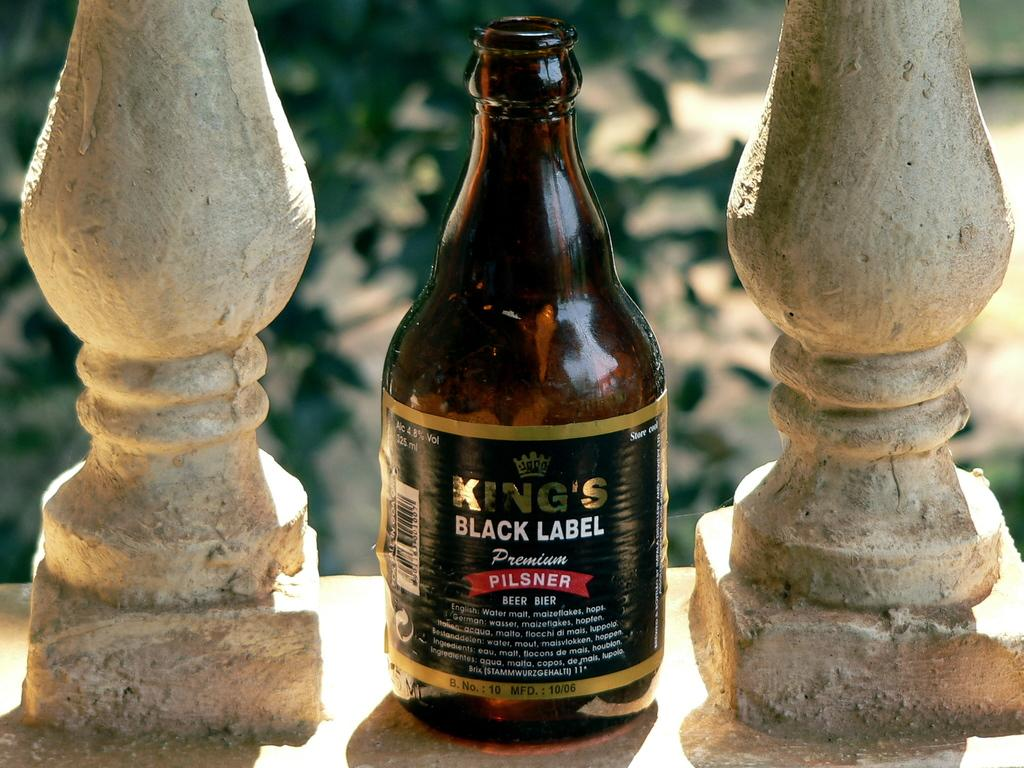What type of bottle is visible in the image? There is a king's black label bottle in the image. How is the bottle positioned in relation to other objects? The bottle is present between two other objects. What type of caption is written on the bottle in the image? There is no caption visible on the bottle in the image; it is a king's black label bottle. Can you see any sea or fog in the image? There is no sea or fog present in the image. 